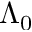Convert formula to latex. <formula><loc_0><loc_0><loc_500><loc_500>\Lambda _ { 0 }</formula> 